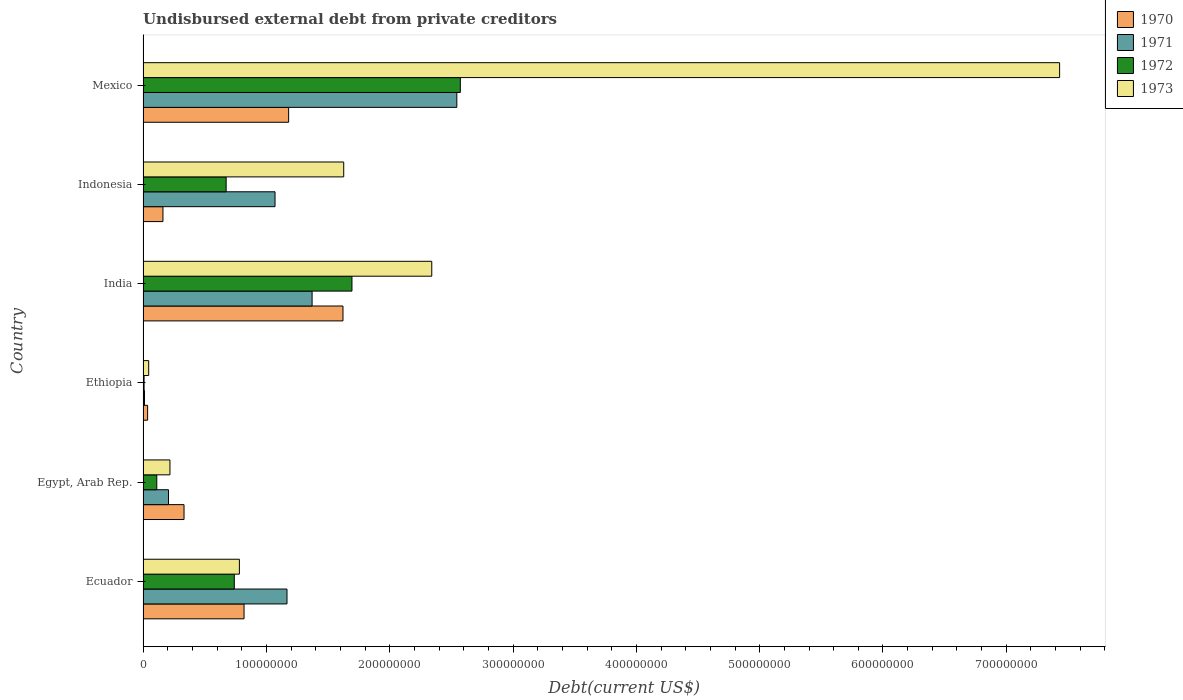How many different coloured bars are there?
Offer a terse response. 4. How many groups of bars are there?
Offer a very short reply. 6. Are the number of bars per tick equal to the number of legend labels?
Your answer should be compact. Yes. Are the number of bars on each tick of the Y-axis equal?
Keep it short and to the point. Yes. How many bars are there on the 3rd tick from the top?
Provide a succinct answer. 4. How many bars are there on the 1st tick from the bottom?
Make the answer very short. 4. What is the label of the 1st group of bars from the top?
Offer a terse response. Mexico. What is the total debt in 1970 in India?
Your answer should be compact. 1.62e+08. Across all countries, what is the maximum total debt in 1973?
Make the answer very short. 7.43e+08. Across all countries, what is the minimum total debt in 1972?
Provide a succinct answer. 8.20e+05. In which country was the total debt in 1970 minimum?
Offer a very short reply. Ethiopia. What is the total total debt in 1971 in the graph?
Provide a succinct answer. 6.37e+08. What is the difference between the total debt in 1972 in Ecuador and that in Egypt, Arab Rep.?
Provide a succinct answer. 6.28e+07. What is the difference between the total debt in 1970 in India and the total debt in 1973 in Ethiopia?
Make the answer very short. 1.58e+08. What is the average total debt in 1972 per country?
Your answer should be very brief. 9.67e+07. What is the difference between the total debt in 1972 and total debt in 1973 in Ecuador?
Provide a succinct answer. -4.14e+06. In how many countries, is the total debt in 1973 greater than 300000000 US$?
Provide a short and direct response. 1. What is the ratio of the total debt in 1972 in Ecuador to that in Indonesia?
Make the answer very short. 1.1. What is the difference between the highest and the second highest total debt in 1970?
Your answer should be very brief. 4.41e+07. What is the difference between the highest and the lowest total debt in 1972?
Give a very brief answer. 2.56e+08. Is the sum of the total debt in 1971 in Egypt, Arab Rep. and Mexico greater than the maximum total debt in 1973 across all countries?
Keep it short and to the point. No. Is it the case that in every country, the sum of the total debt in 1971 and total debt in 1972 is greater than the sum of total debt in 1970 and total debt in 1973?
Ensure brevity in your answer.  No. What does the 1st bar from the top in India represents?
Offer a very short reply. 1973. Is it the case that in every country, the sum of the total debt in 1972 and total debt in 1970 is greater than the total debt in 1971?
Provide a succinct answer. No. What is the difference between two consecutive major ticks on the X-axis?
Provide a short and direct response. 1.00e+08. What is the title of the graph?
Make the answer very short. Undisbursed external debt from private creditors. What is the label or title of the X-axis?
Ensure brevity in your answer.  Debt(current US$). What is the label or title of the Y-axis?
Provide a short and direct response. Country. What is the Debt(current US$) in 1970 in Ecuador?
Offer a very short reply. 8.19e+07. What is the Debt(current US$) in 1971 in Ecuador?
Offer a terse response. 1.17e+08. What is the Debt(current US$) in 1972 in Ecuador?
Offer a very short reply. 7.40e+07. What is the Debt(current US$) of 1973 in Ecuador?
Give a very brief answer. 7.81e+07. What is the Debt(current US$) in 1970 in Egypt, Arab Rep.?
Make the answer very short. 3.32e+07. What is the Debt(current US$) in 1971 in Egypt, Arab Rep.?
Make the answer very short. 2.06e+07. What is the Debt(current US$) of 1972 in Egypt, Arab Rep.?
Provide a succinct answer. 1.11e+07. What is the Debt(current US$) of 1973 in Egypt, Arab Rep.?
Your response must be concise. 2.18e+07. What is the Debt(current US$) of 1970 in Ethiopia?
Make the answer very short. 3.70e+06. What is the Debt(current US$) in 1971 in Ethiopia?
Your response must be concise. 1.16e+06. What is the Debt(current US$) of 1972 in Ethiopia?
Provide a short and direct response. 8.20e+05. What is the Debt(current US$) in 1973 in Ethiopia?
Give a very brief answer. 4.57e+06. What is the Debt(current US$) in 1970 in India?
Keep it short and to the point. 1.62e+08. What is the Debt(current US$) in 1971 in India?
Make the answer very short. 1.37e+08. What is the Debt(current US$) in 1972 in India?
Provide a short and direct response. 1.69e+08. What is the Debt(current US$) in 1973 in India?
Your response must be concise. 2.34e+08. What is the Debt(current US$) in 1970 in Indonesia?
Offer a terse response. 1.61e+07. What is the Debt(current US$) of 1971 in Indonesia?
Offer a terse response. 1.07e+08. What is the Debt(current US$) in 1972 in Indonesia?
Keep it short and to the point. 6.74e+07. What is the Debt(current US$) in 1973 in Indonesia?
Provide a succinct answer. 1.63e+08. What is the Debt(current US$) in 1970 in Mexico?
Keep it short and to the point. 1.18e+08. What is the Debt(current US$) in 1971 in Mexico?
Your answer should be compact. 2.54e+08. What is the Debt(current US$) in 1972 in Mexico?
Your answer should be compact. 2.57e+08. What is the Debt(current US$) of 1973 in Mexico?
Offer a very short reply. 7.43e+08. Across all countries, what is the maximum Debt(current US$) of 1970?
Provide a succinct answer. 1.62e+08. Across all countries, what is the maximum Debt(current US$) in 1971?
Provide a short and direct response. 2.54e+08. Across all countries, what is the maximum Debt(current US$) of 1972?
Provide a succinct answer. 2.57e+08. Across all countries, what is the maximum Debt(current US$) of 1973?
Offer a very short reply. 7.43e+08. Across all countries, what is the minimum Debt(current US$) of 1970?
Ensure brevity in your answer.  3.70e+06. Across all countries, what is the minimum Debt(current US$) in 1971?
Keep it short and to the point. 1.16e+06. Across all countries, what is the minimum Debt(current US$) in 1972?
Your response must be concise. 8.20e+05. Across all countries, what is the minimum Debt(current US$) of 1973?
Keep it short and to the point. 4.57e+06. What is the total Debt(current US$) of 1970 in the graph?
Give a very brief answer. 4.15e+08. What is the total Debt(current US$) of 1971 in the graph?
Offer a terse response. 6.37e+08. What is the total Debt(current US$) of 1972 in the graph?
Offer a very short reply. 5.80e+08. What is the total Debt(current US$) of 1973 in the graph?
Offer a terse response. 1.24e+09. What is the difference between the Debt(current US$) in 1970 in Ecuador and that in Egypt, Arab Rep.?
Make the answer very short. 4.87e+07. What is the difference between the Debt(current US$) of 1971 in Ecuador and that in Egypt, Arab Rep.?
Provide a succinct answer. 9.61e+07. What is the difference between the Debt(current US$) in 1972 in Ecuador and that in Egypt, Arab Rep.?
Give a very brief answer. 6.28e+07. What is the difference between the Debt(current US$) in 1973 in Ecuador and that in Egypt, Arab Rep.?
Make the answer very short. 5.63e+07. What is the difference between the Debt(current US$) in 1970 in Ecuador and that in Ethiopia?
Keep it short and to the point. 7.82e+07. What is the difference between the Debt(current US$) in 1971 in Ecuador and that in Ethiopia?
Your answer should be very brief. 1.16e+08. What is the difference between the Debt(current US$) in 1972 in Ecuador and that in Ethiopia?
Provide a short and direct response. 7.32e+07. What is the difference between the Debt(current US$) in 1973 in Ecuador and that in Ethiopia?
Offer a very short reply. 7.35e+07. What is the difference between the Debt(current US$) in 1970 in Ecuador and that in India?
Give a very brief answer. -8.02e+07. What is the difference between the Debt(current US$) of 1971 in Ecuador and that in India?
Your response must be concise. -2.03e+07. What is the difference between the Debt(current US$) in 1972 in Ecuador and that in India?
Your response must be concise. -9.54e+07. What is the difference between the Debt(current US$) in 1973 in Ecuador and that in India?
Keep it short and to the point. -1.56e+08. What is the difference between the Debt(current US$) in 1970 in Ecuador and that in Indonesia?
Give a very brief answer. 6.58e+07. What is the difference between the Debt(current US$) in 1971 in Ecuador and that in Indonesia?
Offer a terse response. 9.70e+06. What is the difference between the Debt(current US$) in 1972 in Ecuador and that in Indonesia?
Provide a succinct answer. 6.60e+06. What is the difference between the Debt(current US$) in 1973 in Ecuador and that in Indonesia?
Provide a short and direct response. -8.46e+07. What is the difference between the Debt(current US$) of 1970 in Ecuador and that in Mexico?
Ensure brevity in your answer.  -3.62e+07. What is the difference between the Debt(current US$) in 1971 in Ecuador and that in Mexico?
Make the answer very short. -1.38e+08. What is the difference between the Debt(current US$) of 1972 in Ecuador and that in Mexico?
Make the answer very short. -1.83e+08. What is the difference between the Debt(current US$) in 1973 in Ecuador and that in Mexico?
Provide a short and direct response. -6.65e+08. What is the difference between the Debt(current US$) in 1970 in Egypt, Arab Rep. and that in Ethiopia?
Ensure brevity in your answer.  2.95e+07. What is the difference between the Debt(current US$) in 1971 in Egypt, Arab Rep. and that in Ethiopia?
Ensure brevity in your answer.  1.95e+07. What is the difference between the Debt(current US$) in 1972 in Egypt, Arab Rep. and that in Ethiopia?
Your answer should be very brief. 1.03e+07. What is the difference between the Debt(current US$) in 1973 in Egypt, Arab Rep. and that in Ethiopia?
Your answer should be very brief. 1.72e+07. What is the difference between the Debt(current US$) of 1970 in Egypt, Arab Rep. and that in India?
Provide a succinct answer. -1.29e+08. What is the difference between the Debt(current US$) in 1971 in Egypt, Arab Rep. and that in India?
Give a very brief answer. -1.16e+08. What is the difference between the Debt(current US$) of 1972 in Egypt, Arab Rep. and that in India?
Give a very brief answer. -1.58e+08. What is the difference between the Debt(current US$) in 1973 in Egypt, Arab Rep. and that in India?
Your answer should be compact. -2.12e+08. What is the difference between the Debt(current US$) in 1970 in Egypt, Arab Rep. and that in Indonesia?
Your answer should be very brief. 1.71e+07. What is the difference between the Debt(current US$) of 1971 in Egypt, Arab Rep. and that in Indonesia?
Offer a very short reply. -8.64e+07. What is the difference between the Debt(current US$) of 1972 in Egypt, Arab Rep. and that in Indonesia?
Your response must be concise. -5.62e+07. What is the difference between the Debt(current US$) in 1973 in Egypt, Arab Rep. and that in Indonesia?
Your response must be concise. -1.41e+08. What is the difference between the Debt(current US$) of 1970 in Egypt, Arab Rep. and that in Mexico?
Your answer should be very brief. -8.48e+07. What is the difference between the Debt(current US$) of 1971 in Egypt, Arab Rep. and that in Mexico?
Make the answer very short. -2.34e+08. What is the difference between the Debt(current US$) of 1972 in Egypt, Arab Rep. and that in Mexico?
Make the answer very short. -2.46e+08. What is the difference between the Debt(current US$) of 1973 in Egypt, Arab Rep. and that in Mexico?
Provide a short and direct response. -7.21e+08. What is the difference between the Debt(current US$) in 1970 in Ethiopia and that in India?
Provide a short and direct response. -1.58e+08. What is the difference between the Debt(current US$) in 1971 in Ethiopia and that in India?
Offer a terse response. -1.36e+08. What is the difference between the Debt(current US$) of 1972 in Ethiopia and that in India?
Offer a very short reply. -1.69e+08. What is the difference between the Debt(current US$) of 1973 in Ethiopia and that in India?
Your answer should be compact. -2.30e+08. What is the difference between the Debt(current US$) in 1970 in Ethiopia and that in Indonesia?
Offer a very short reply. -1.24e+07. What is the difference between the Debt(current US$) of 1971 in Ethiopia and that in Indonesia?
Provide a succinct answer. -1.06e+08. What is the difference between the Debt(current US$) in 1972 in Ethiopia and that in Indonesia?
Your response must be concise. -6.66e+07. What is the difference between the Debt(current US$) of 1973 in Ethiopia and that in Indonesia?
Give a very brief answer. -1.58e+08. What is the difference between the Debt(current US$) in 1970 in Ethiopia and that in Mexico?
Offer a very short reply. -1.14e+08. What is the difference between the Debt(current US$) of 1971 in Ethiopia and that in Mexico?
Offer a terse response. -2.53e+08. What is the difference between the Debt(current US$) of 1972 in Ethiopia and that in Mexico?
Give a very brief answer. -2.56e+08. What is the difference between the Debt(current US$) of 1973 in Ethiopia and that in Mexico?
Provide a short and direct response. -7.39e+08. What is the difference between the Debt(current US$) in 1970 in India and that in Indonesia?
Provide a short and direct response. 1.46e+08. What is the difference between the Debt(current US$) in 1971 in India and that in Indonesia?
Offer a terse response. 3.00e+07. What is the difference between the Debt(current US$) in 1972 in India and that in Indonesia?
Offer a terse response. 1.02e+08. What is the difference between the Debt(current US$) of 1973 in India and that in Indonesia?
Your response must be concise. 7.14e+07. What is the difference between the Debt(current US$) in 1970 in India and that in Mexico?
Provide a succinct answer. 4.41e+07. What is the difference between the Debt(current US$) in 1971 in India and that in Mexico?
Keep it short and to the point. -1.17e+08. What is the difference between the Debt(current US$) of 1972 in India and that in Mexico?
Offer a very short reply. -8.79e+07. What is the difference between the Debt(current US$) of 1973 in India and that in Mexico?
Provide a short and direct response. -5.09e+08. What is the difference between the Debt(current US$) of 1970 in Indonesia and that in Mexico?
Provide a succinct answer. -1.02e+08. What is the difference between the Debt(current US$) of 1971 in Indonesia and that in Mexico?
Your answer should be very brief. -1.47e+08. What is the difference between the Debt(current US$) in 1972 in Indonesia and that in Mexico?
Make the answer very short. -1.90e+08. What is the difference between the Debt(current US$) of 1973 in Indonesia and that in Mexico?
Your response must be concise. -5.81e+08. What is the difference between the Debt(current US$) in 1970 in Ecuador and the Debt(current US$) in 1971 in Egypt, Arab Rep.?
Your response must be concise. 6.13e+07. What is the difference between the Debt(current US$) of 1970 in Ecuador and the Debt(current US$) of 1972 in Egypt, Arab Rep.?
Give a very brief answer. 7.08e+07. What is the difference between the Debt(current US$) of 1970 in Ecuador and the Debt(current US$) of 1973 in Egypt, Arab Rep.?
Your response must be concise. 6.01e+07. What is the difference between the Debt(current US$) of 1971 in Ecuador and the Debt(current US$) of 1972 in Egypt, Arab Rep.?
Your response must be concise. 1.06e+08. What is the difference between the Debt(current US$) of 1971 in Ecuador and the Debt(current US$) of 1973 in Egypt, Arab Rep.?
Ensure brevity in your answer.  9.49e+07. What is the difference between the Debt(current US$) of 1972 in Ecuador and the Debt(current US$) of 1973 in Egypt, Arab Rep.?
Give a very brief answer. 5.22e+07. What is the difference between the Debt(current US$) in 1970 in Ecuador and the Debt(current US$) in 1971 in Ethiopia?
Offer a very short reply. 8.07e+07. What is the difference between the Debt(current US$) in 1970 in Ecuador and the Debt(current US$) in 1972 in Ethiopia?
Make the answer very short. 8.11e+07. What is the difference between the Debt(current US$) in 1970 in Ecuador and the Debt(current US$) in 1973 in Ethiopia?
Provide a short and direct response. 7.73e+07. What is the difference between the Debt(current US$) of 1971 in Ecuador and the Debt(current US$) of 1972 in Ethiopia?
Provide a succinct answer. 1.16e+08. What is the difference between the Debt(current US$) of 1971 in Ecuador and the Debt(current US$) of 1973 in Ethiopia?
Make the answer very short. 1.12e+08. What is the difference between the Debt(current US$) of 1972 in Ecuador and the Debt(current US$) of 1973 in Ethiopia?
Keep it short and to the point. 6.94e+07. What is the difference between the Debt(current US$) of 1970 in Ecuador and the Debt(current US$) of 1971 in India?
Your answer should be compact. -5.52e+07. What is the difference between the Debt(current US$) of 1970 in Ecuador and the Debt(current US$) of 1972 in India?
Your answer should be compact. -8.75e+07. What is the difference between the Debt(current US$) in 1970 in Ecuador and the Debt(current US$) in 1973 in India?
Your answer should be compact. -1.52e+08. What is the difference between the Debt(current US$) in 1971 in Ecuador and the Debt(current US$) in 1972 in India?
Your answer should be very brief. -5.27e+07. What is the difference between the Debt(current US$) of 1971 in Ecuador and the Debt(current US$) of 1973 in India?
Keep it short and to the point. -1.17e+08. What is the difference between the Debt(current US$) of 1972 in Ecuador and the Debt(current US$) of 1973 in India?
Keep it short and to the point. -1.60e+08. What is the difference between the Debt(current US$) in 1970 in Ecuador and the Debt(current US$) in 1971 in Indonesia?
Provide a succinct answer. -2.51e+07. What is the difference between the Debt(current US$) in 1970 in Ecuador and the Debt(current US$) in 1972 in Indonesia?
Your answer should be compact. 1.45e+07. What is the difference between the Debt(current US$) in 1970 in Ecuador and the Debt(current US$) in 1973 in Indonesia?
Your answer should be very brief. -8.08e+07. What is the difference between the Debt(current US$) of 1971 in Ecuador and the Debt(current US$) of 1972 in Indonesia?
Your response must be concise. 4.93e+07. What is the difference between the Debt(current US$) in 1971 in Ecuador and the Debt(current US$) in 1973 in Indonesia?
Your answer should be compact. -4.60e+07. What is the difference between the Debt(current US$) of 1972 in Ecuador and the Debt(current US$) of 1973 in Indonesia?
Provide a short and direct response. -8.87e+07. What is the difference between the Debt(current US$) in 1970 in Ecuador and the Debt(current US$) in 1971 in Mexico?
Your response must be concise. -1.73e+08. What is the difference between the Debt(current US$) of 1970 in Ecuador and the Debt(current US$) of 1972 in Mexico?
Provide a short and direct response. -1.75e+08. What is the difference between the Debt(current US$) in 1970 in Ecuador and the Debt(current US$) in 1973 in Mexico?
Your answer should be very brief. -6.61e+08. What is the difference between the Debt(current US$) of 1971 in Ecuador and the Debt(current US$) of 1972 in Mexico?
Provide a short and direct response. -1.41e+08. What is the difference between the Debt(current US$) of 1971 in Ecuador and the Debt(current US$) of 1973 in Mexico?
Your answer should be very brief. -6.27e+08. What is the difference between the Debt(current US$) of 1972 in Ecuador and the Debt(current US$) of 1973 in Mexico?
Your answer should be compact. -6.69e+08. What is the difference between the Debt(current US$) of 1970 in Egypt, Arab Rep. and the Debt(current US$) of 1971 in Ethiopia?
Make the answer very short. 3.21e+07. What is the difference between the Debt(current US$) of 1970 in Egypt, Arab Rep. and the Debt(current US$) of 1972 in Ethiopia?
Give a very brief answer. 3.24e+07. What is the difference between the Debt(current US$) of 1970 in Egypt, Arab Rep. and the Debt(current US$) of 1973 in Ethiopia?
Give a very brief answer. 2.87e+07. What is the difference between the Debt(current US$) of 1971 in Egypt, Arab Rep. and the Debt(current US$) of 1972 in Ethiopia?
Make the answer very short. 1.98e+07. What is the difference between the Debt(current US$) in 1971 in Egypt, Arab Rep. and the Debt(current US$) in 1973 in Ethiopia?
Ensure brevity in your answer.  1.61e+07. What is the difference between the Debt(current US$) in 1972 in Egypt, Arab Rep. and the Debt(current US$) in 1973 in Ethiopia?
Make the answer very short. 6.56e+06. What is the difference between the Debt(current US$) in 1970 in Egypt, Arab Rep. and the Debt(current US$) in 1971 in India?
Offer a very short reply. -1.04e+08. What is the difference between the Debt(current US$) of 1970 in Egypt, Arab Rep. and the Debt(current US$) of 1972 in India?
Ensure brevity in your answer.  -1.36e+08. What is the difference between the Debt(current US$) in 1970 in Egypt, Arab Rep. and the Debt(current US$) in 1973 in India?
Provide a succinct answer. -2.01e+08. What is the difference between the Debt(current US$) in 1971 in Egypt, Arab Rep. and the Debt(current US$) in 1972 in India?
Give a very brief answer. -1.49e+08. What is the difference between the Debt(current US$) of 1971 in Egypt, Arab Rep. and the Debt(current US$) of 1973 in India?
Offer a terse response. -2.13e+08. What is the difference between the Debt(current US$) of 1972 in Egypt, Arab Rep. and the Debt(current US$) of 1973 in India?
Ensure brevity in your answer.  -2.23e+08. What is the difference between the Debt(current US$) of 1970 in Egypt, Arab Rep. and the Debt(current US$) of 1971 in Indonesia?
Ensure brevity in your answer.  -7.38e+07. What is the difference between the Debt(current US$) in 1970 in Egypt, Arab Rep. and the Debt(current US$) in 1972 in Indonesia?
Provide a succinct answer. -3.42e+07. What is the difference between the Debt(current US$) of 1970 in Egypt, Arab Rep. and the Debt(current US$) of 1973 in Indonesia?
Provide a succinct answer. -1.29e+08. What is the difference between the Debt(current US$) of 1971 in Egypt, Arab Rep. and the Debt(current US$) of 1972 in Indonesia?
Your answer should be very brief. -4.67e+07. What is the difference between the Debt(current US$) of 1971 in Egypt, Arab Rep. and the Debt(current US$) of 1973 in Indonesia?
Make the answer very short. -1.42e+08. What is the difference between the Debt(current US$) of 1972 in Egypt, Arab Rep. and the Debt(current US$) of 1973 in Indonesia?
Give a very brief answer. -1.52e+08. What is the difference between the Debt(current US$) of 1970 in Egypt, Arab Rep. and the Debt(current US$) of 1971 in Mexico?
Offer a very short reply. -2.21e+08. What is the difference between the Debt(current US$) of 1970 in Egypt, Arab Rep. and the Debt(current US$) of 1972 in Mexico?
Your response must be concise. -2.24e+08. What is the difference between the Debt(current US$) of 1970 in Egypt, Arab Rep. and the Debt(current US$) of 1973 in Mexico?
Your response must be concise. -7.10e+08. What is the difference between the Debt(current US$) of 1971 in Egypt, Arab Rep. and the Debt(current US$) of 1972 in Mexico?
Give a very brief answer. -2.37e+08. What is the difference between the Debt(current US$) in 1971 in Egypt, Arab Rep. and the Debt(current US$) in 1973 in Mexico?
Provide a short and direct response. -7.23e+08. What is the difference between the Debt(current US$) in 1972 in Egypt, Arab Rep. and the Debt(current US$) in 1973 in Mexico?
Offer a terse response. -7.32e+08. What is the difference between the Debt(current US$) in 1970 in Ethiopia and the Debt(current US$) in 1971 in India?
Offer a very short reply. -1.33e+08. What is the difference between the Debt(current US$) of 1970 in Ethiopia and the Debt(current US$) of 1972 in India?
Ensure brevity in your answer.  -1.66e+08. What is the difference between the Debt(current US$) of 1970 in Ethiopia and the Debt(current US$) of 1973 in India?
Ensure brevity in your answer.  -2.30e+08. What is the difference between the Debt(current US$) in 1971 in Ethiopia and the Debt(current US$) in 1972 in India?
Your response must be concise. -1.68e+08. What is the difference between the Debt(current US$) in 1971 in Ethiopia and the Debt(current US$) in 1973 in India?
Your answer should be compact. -2.33e+08. What is the difference between the Debt(current US$) of 1972 in Ethiopia and the Debt(current US$) of 1973 in India?
Give a very brief answer. -2.33e+08. What is the difference between the Debt(current US$) of 1970 in Ethiopia and the Debt(current US$) of 1971 in Indonesia?
Offer a very short reply. -1.03e+08. What is the difference between the Debt(current US$) in 1970 in Ethiopia and the Debt(current US$) in 1972 in Indonesia?
Your answer should be compact. -6.37e+07. What is the difference between the Debt(current US$) of 1970 in Ethiopia and the Debt(current US$) of 1973 in Indonesia?
Your response must be concise. -1.59e+08. What is the difference between the Debt(current US$) in 1971 in Ethiopia and the Debt(current US$) in 1972 in Indonesia?
Ensure brevity in your answer.  -6.62e+07. What is the difference between the Debt(current US$) in 1971 in Ethiopia and the Debt(current US$) in 1973 in Indonesia?
Your answer should be compact. -1.62e+08. What is the difference between the Debt(current US$) of 1972 in Ethiopia and the Debt(current US$) of 1973 in Indonesia?
Your response must be concise. -1.62e+08. What is the difference between the Debt(current US$) in 1970 in Ethiopia and the Debt(current US$) in 1971 in Mexico?
Make the answer very short. -2.51e+08. What is the difference between the Debt(current US$) of 1970 in Ethiopia and the Debt(current US$) of 1972 in Mexico?
Make the answer very short. -2.54e+08. What is the difference between the Debt(current US$) of 1970 in Ethiopia and the Debt(current US$) of 1973 in Mexico?
Your response must be concise. -7.40e+08. What is the difference between the Debt(current US$) in 1971 in Ethiopia and the Debt(current US$) in 1972 in Mexico?
Keep it short and to the point. -2.56e+08. What is the difference between the Debt(current US$) of 1971 in Ethiopia and the Debt(current US$) of 1973 in Mexico?
Make the answer very short. -7.42e+08. What is the difference between the Debt(current US$) of 1972 in Ethiopia and the Debt(current US$) of 1973 in Mexico?
Offer a terse response. -7.42e+08. What is the difference between the Debt(current US$) of 1970 in India and the Debt(current US$) of 1971 in Indonesia?
Give a very brief answer. 5.51e+07. What is the difference between the Debt(current US$) of 1970 in India and the Debt(current US$) of 1972 in Indonesia?
Your answer should be compact. 9.47e+07. What is the difference between the Debt(current US$) of 1970 in India and the Debt(current US$) of 1973 in Indonesia?
Your answer should be very brief. -5.84e+05. What is the difference between the Debt(current US$) of 1971 in India and the Debt(current US$) of 1972 in Indonesia?
Offer a terse response. 6.97e+07. What is the difference between the Debt(current US$) in 1971 in India and the Debt(current US$) in 1973 in Indonesia?
Provide a short and direct response. -2.56e+07. What is the difference between the Debt(current US$) in 1972 in India and the Debt(current US$) in 1973 in Indonesia?
Your answer should be very brief. 6.68e+06. What is the difference between the Debt(current US$) in 1970 in India and the Debt(current US$) in 1971 in Mexico?
Keep it short and to the point. -9.23e+07. What is the difference between the Debt(current US$) of 1970 in India and the Debt(current US$) of 1972 in Mexico?
Give a very brief answer. -9.51e+07. What is the difference between the Debt(current US$) of 1970 in India and the Debt(current US$) of 1973 in Mexico?
Ensure brevity in your answer.  -5.81e+08. What is the difference between the Debt(current US$) in 1971 in India and the Debt(current US$) in 1972 in Mexico?
Offer a terse response. -1.20e+08. What is the difference between the Debt(current US$) of 1971 in India and the Debt(current US$) of 1973 in Mexico?
Provide a succinct answer. -6.06e+08. What is the difference between the Debt(current US$) in 1972 in India and the Debt(current US$) in 1973 in Mexico?
Ensure brevity in your answer.  -5.74e+08. What is the difference between the Debt(current US$) of 1970 in Indonesia and the Debt(current US$) of 1971 in Mexico?
Your response must be concise. -2.38e+08. What is the difference between the Debt(current US$) of 1970 in Indonesia and the Debt(current US$) of 1972 in Mexico?
Your answer should be compact. -2.41e+08. What is the difference between the Debt(current US$) in 1970 in Indonesia and the Debt(current US$) in 1973 in Mexico?
Your answer should be compact. -7.27e+08. What is the difference between the Debt(current US$) in 1971 in Indonesia and the Debt(current US$) in 1972 in Mexico?
Ensure brevity in your answer.  -1.50e+08. What is the difference between the Debt(current US$) in 1971 in Indonesia and the Debt(current US$) in 1973 in Mexico?
Offer a very short reply. -6.36e+08. What is the difference between the Debt(current US$) of 1972 in Indonesia and the Debt(current US$) of 1973 in Mexico?
Offer a terse response. -6.76e+08. What is the average Debt(current US$) of 1970 per country?
Provide a succinct answer. 6.92e+07. What is the average Debt(current US$) of 1971 per country?
Provide a short and direct response. 1.06e+08. What is the average Debt(current US$) in 1972 per country?
Provide a succinct answer. 9.67e+07. What is the average Debt(current US$) in 1973 per country?
Provide a short and direct response. 2.07e+08. What is the difference between the Debt(current US$) in 1970 and Debt(current US$) in 1971 in Ecuador?
Ensure brevity in your answer.  -3.48e+07. What is the difference between the Debt(current US$) of 1970 and Debt(current US$) of 1972 in Ecuador?
Provide a succinct answer. 7.92e+06. What is the difference between the Debt(current US$) of 1970 and Debt(current US$) of 1973 in Ecuador?
Offer a very short reply. 3.78e+06. What is the difference between the Debt(current US$) of 1971 and Debt(current US$) of 1972 in Ecuador?
Provide a succinct answer. 4.27e+07. What is the difference between the Debt(current US$) of 1971 and Debt(current US$) of 1973 in Ecuador?
Ensure brevity in your answer.  3.86e+07. What is the difference between the Debt(current US$) in 1972 and Debt(current US$) in 1973 in Ecuador?
Your answer should be very brief. -4.14e+06. What is the difference between the Debt(current US$) of 1970 and Debt(current US$) of 1971 in Egypt, Arab Rep.?
Give a very brief answer. 1.26e+07. What is the difference between the Debt(current US$) of 1970 and Debt(current US$) of 1972 in Egypt, Arab Rep.?
Your answer should be very brief. 2.21e+07. What is the difference between the Debt(current US$) in 1970 and Debt(current US$) in 1973 in Egypt, Arab Rep.?
Your answer should be compact. 1.14e+07. What is the difference between the Debt(current US$) in 1971 and Debt(current US$) in 1972 in Egypt, Arab Rep.?
Keep it short and to the point. 9.50e+06. What is the difference between the Debt(current US$) of 1971 and Debt(current US$) of 1973 in Egypt, Arab Rep.?
Keep it short and to the point. -1.17e+06. What is the difference between the Debt(current US$) in 1972 and Debt(current US$) in 1973 in Egypt, Arab Rep.?
Provide a short and direct response. -1.07e+07. What is the difference between the Debt(current US$) in 1970 and Debt(current US$) in 1971 in Ethiopia?
Provide a succinct answer. 2.53e+06. What is the difference between the Debt(current US$) of 1970 and Debt(current US$) of 1972 in Ethiopia?
Provide a short and direct response. 2.88e+06. What is the difference between the Debt(current US$) in 1970 and Debt(current US$) in 1973 in Ethiopia?
Keep it short and to the point. -8.70e+05. What is the difference between the Debt(current US$) in 1971 and Debt(current US$) in 1972 in Ethiopia?
Ensure brevity in your answer.  3.45e+05. What is the difference between the Debt(current US$) of 1971 and Debt(current US$) of 1973 in Ethiopia?
Keep it short and to the point. -3.40e+06. What is the difference between the Debt(current US$) of 1972 and Debt(current US$) of 1973 in Ethiopia?
Your answer should be very brief. -3.75e+06. What is the difference between the Debt(current US$) in 1970 and Debt(current US$) in 1971 in India?
Keep it short and to the point. 2.51e+07. What is the difference between the Debt(current US$) of 1970 and Debt(current US$) of 1972 in India?
Keep it short and to the point. -7.26e+06. What is the difference between the Debt(current US$) in 1970 and Debt(current US$) in 1973 in India?
Keep it short and to the point. -7.20e+07. What is the difference between the Debt(current US$) in 1971 and Debt(current US$) in 1972 in India?
Make the answer very short. -3.23e+07. What is the difference between the Debt(current US$) in 1971 and Debt(current US$) in 1973 in India?
Provide a succinct answer. -9.70e+07. What is the difference between the Debt(current US$) in 1972 and Debt(current US$) in 1973 in India?
Offer a terse response. -6.47e+07. What is the difference between the Debt(current US$) of 1970 and Debt(current US$) of 1971 in Indonesia?
Ensure brevity in your answer.  -9.09e+07. What is the difference between the Debt(current US$) in 1970 and Debt(current US$) in 1972 in Indonesia?
Your response must be concise. -5.12e+07. What is the difference between the Debt(current US$) of 1970 and Debt(current US$) of 1973 in Indonesia?
Make the answer very short. -1.47e+08. What is the difference between the Debt(current US$) of 1971 and Debt(current US$) of 1972 in Indonesia?
Your response must be concise. 3.96e+07. What is the difference between the Debt(current US$) of 1971 and Debt(current US$) of 1973 in Indonesia?
Provide a succinct answer. -5.57e+07. What is the difference between the Debt(current US$) of 1972 and Debt(current US$) of 1973 in Indonesia?
Keep it short and to the point. -9.53e+07. What is the difference between the Debt(current US$) in 1970 and Debt(current US$) in 1971 in Mexico?
Provide a succinct answer. -1.36e+08. What is the difference between the Debt(current US$) in 1970 and Debt(current US$) in 1972 in Mexico?
Your answer should be compact. -1.39e+08. What is the difference between the Debt(current US$) of 1970 and Debt(current US$) of 1973 in Mexico?
Provide a succinct answer. -6.25e+08. What is the difference between the Debt(current US$) in 1971 and Debt(current US$) in 1972 in Mexico?
Provide a short and direct response. -2.84e+06. What is the difference between the Debt(current US$) of 1971 and Debt(current US$) of 1973 in Mexico?
Give a very brief answer. -4.89e+08. What is the difference between the Debt(current US$) in 1972 and Debt(current US$) in 1973 in Mexico?
Your response must be concise. -4.86e+08. What is the ratio of the Debt(current US$) in 1970 in Ecuador to that in Egypt, Arab Rep.?
Give a very brief answer. 2.47. What is the ratio of the Debt(current US$) in 1971 in Ecuador to that in Egypt, Arab Rep.?
Your answer should be very brief. 5.66. What is the ratio of the Debt(current US$) in 1972 in Ecuador to that in Egypt, Arab Rep.?
Offer a terse response. 6.65. What is the ratio of the Debt(current US$) in 1973 in Ecuador to that in Egypt, Arab Rep.?
Provide a succinct answer. 3.58. What is the ratio of the Debt(current US$) of 1970 in Ecuador to that in Ethiopia?
Offer a very short reply. 22.15. What is the ratio of the Debt(current US$) of 1971 in Ecuador to that in Ethiopia?
Your answer should be compact. 100.19. What is the ratio of the Debt(current US$) of 1972 in Ecuador to that in Ethiopia?
Make the answer very short. 90.21. What is the ratio of the Debt(current US$) in 1973 in Ecuador to that in Ethiopia?
Offer a very short reply. 17.1. What is the ratio of the Debt(current US$) in 1970 in Ecuador to that in India?
Provide a short and direct response. 0.51. What is the ratio of the Debt(current US$) of 1971 in Ecuador to that in India?
Your answer should be very brief. 0.85. What is the ratio of the Debt(current US$) in 1972 in Ecuador to that in India?
Give a very brief answer. 0.44. What is the ratio of the Debt(current US$) in 1973 in Ecuador to that in India?
Keep it short and to the point. 0.33. What is the ratio of the Debt(current US$) of 1970 in Ecuador to that in Indonesia?
Make the answer very short. 5.08. What is the ratio of the Debt(current US$) in 1971 in Ecuador to that in Indonesia?
Your response must be concise. 1.09. What is the ratio of the Debt(current US$) of 1972 in Ecuador to that in Indonesia?
Give a very brief answer. 1.1. What is the ratio of the Debt(current US$) in 1973 in Ecuador to that in Indonesia?
Ensure brevity in your answer.  0.48. What is the ratio of the Debt(current US$) of 1970 in Ecuador to that in Mexico?
Your answer should be very brief. 0.69. What is the ratio of the Debt(current US$) of 1971 in Ecuador to that in Mexico?
Your answer should be very brief. 0.46. What is the ratio of the Debt(current US$) in 1972 in Ecuador to that in Mexico?
Ensure brevity in your answer.  0.29. What is the ratio of the Debt(current US$) in 1973 in Ecuador to that in Mexico?
Make the answer very short. 0.11. What is the ratio of the Debt(current US$) of 1970 in Egypt, Arab Rep. to that in Ethiopia?
Provide a short and direct response. 8.99. What is the ratio of the Debt(current US$) of 1971 in Egypt, Arab Rep. to that in Ethiopia?
Ensure brevity in your answer.  17.71. What is the ratio of the Debt(current US$) of 1972 in Egypt, Arab Rep. to that in Ethiopia?
Offer a terse response. 13.57. What is the ratio of the Debt(current US$) of 1973 in Egypt, Arab Rep. to that in Ethiopia?
Offer a terse response. 4.77. What is the ratio of the Debt(current US$) of 1970 in Egypt, Arab Rep. to that in India?
Your response must be concise. 0.2. What is the ratio of the Debt(current US$) of 1971 in Egypt, Arab Rep. to that in India?
Ensure brevity in your answer.  0.15. What is the ratio of the Debt(current US$) in 1972 in Egypt, Arab Rep. to that in India?
Offer a terse response. 0.07. What is the ratio of the Debt(current US$) in 1973 in Egypt, Arab Rep. to that in India?
Provide a short and direct response. 0.09. What is the ratio of the Debt(current US$) in 1970 in Egypt, Arab Rep. to that in Indonesia?
Ensure brevity in your answer.  2.06. What is the ratio of the Debt(current US$) in 1971 in Egypt, Arab Rep. to that in Indonesia?
Provide a short and direct response. 0.19. What is the ratio of the Debt(current US$) in 1972 in Egypt, Arab Rep. to that in Indonesia?
Your response must be concise. 0.17. What is the ratio of the Debt(current US$) of 1973 in Egypt, Arab Rep. to that in Indonesia?
Provide a short and direct response. 0.13. What is the ratio of the Debt(current US$) in 1970 in Egypt, Arab Rep. to that in Mexico?
Keep it short and to the point. 0.28. What is the ratio of the Debt(current US$) in 1971 in Egypt, Arab Rep. to that in Mexico?
Offer a very short reply. 0.08. What is the ratio of the Debt(current US$) of 1972 in Egypt, Arab Rep. to that in Mexico?
Make the answer very short. 0.04. What is the ratio of the Debt(current US$) of 1973 in Egypt, Arab Rep. to that in Mexico?
Your answer should be very brief. 0.03. What is the ratio of the Debt(current US$) of 1970 in Ethiopia to that in India?
Your response must be concise. 0.02. What is the ratio of the Debt(current US$) in 1971 in Ethiopia to that in India?
Your answer should be compact. 0.01. What is the ratio of the Debt(current US$) in 1972 in Ethiopia to that in India?
Ensure brevity in your answer.  0. What is the ratio of the Debt(current US$) of 1973 in Ethiopia to that in India?
Provide a short and direct response. 0.02. What is the ratio of the Debt(current US$) in 1970 in Ethiopia to that in Indonesia?
Ensure brevity in your answer.  0.23. What is the ratio of the Debt(current US$) in 1971 in Ethiopia to that in Indonesia?
Your answer should be compact. 0.01. What is the ratio of the Debt(current US$) in 1972 in Ethiopia to that in Indonesia?
Your answer should be compact. 0.01. What is the ratio of the Debt(current US$) in 1973 in Ethiopia to that in Indonesia?
Give a very brief answer. 0.03. What is the ratio of the Debt(current US$) in 1970 in Ethiopia to that in Mexico?
Provide a succinct answer. 0.03. What is the ratio of the Debt(current US$) in 1971 in Ethiopia to that in Mexico?
Ensure brevity in your answer.  0. What is the ratio of the Debt(current US$) in 1972 in Ethiopia to that in Mexico?
Ensure brevity in your answer.  0. What is the ratio of the Debt(current US$) of 1973 in Ethiopia to that in Mexico?
Your answer should be compact. 0.01. What is the ratio of the Debt(current US$) in 1970 in India to that in Indonesia?
Offer a very short reply. 10.05. What is the ratio of the Debt(current US$) in 1971 in India to that in Indonesia?
Offer a very short reply. 1.28. What is the ratio of the Debt(current US$) of 1972 in India to that in Indonesia?
Offer a very short reply. 2.51. What is the ratio of the Debt(current US$) of 1973 in India to that in Indonesia?
Your answer should be very brief. 1.44. What is the ratio of the Debt(current US$) in 1970 in India to that in Mexico?
Ensure brevity in your answer.  1.37. What is the ratio of the Debt(current US$) of 1971 in India to that in Mexico?
Make the answer very short. 0.54. What is the ratio of the Debt(current US$) of 1972 in India to that in Mexico?
Your answer should be very brief. 0.66. What is the ratio of the Debt(current US$) of 1973 in India to that in Mexico?
Offer a terse response. 0.32. What is the ratio of the Debt(current US$) of 1970 in Indonesia to that in Mexico?
Provide a short and direct response. 0.14. What is the ratio of the Debt(current US$) in 1971 in Indonesia to that in Mexico?
Make the answer very short. 0.42. What is the ratio of the Debt(current US$) of 1972 in Indonesia to that in Mexico?
Provide a short and direct response. 0.26. What is the ratio of the Debt(current US$) in 1973 in Indonesia to that in Mexico?
Your response must be concise. 0.22. What is the difference between the highest and the second highest Debt(current US$) of 1970?
Ensure brevity in your answer.  4.41e+07. What is the difference between the highest and the second highest Debt(current US$) in 1971?
Provide a succinct answer. 1.17e+08. What is the difference between the highest and the second highest Debt(current US$) in 1972?
Make the answer very short. 8.79e+07. What is the difference between the highest and the second highest Debt(current US$) in 1973?
Keep it short and to the point. 5.09e+08. What is the difference between the highest and the lowest Debt(current US$) of 1970?
Offer a terse response. 1.58e+08. What is the difference between the highest and the lowest Debt(current US$) of 1971?
Your answer should be compact. 2.53e+08. What is the difference between the highest and the lowest Debt(current US$) of 1972?
Your answer should be very brief. 2.56e+08. What is the difference between the highest and the lowest Debt(current US$) in 1973?
Provide a short and direct response. 7.39e+08. 